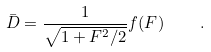Convert formula to latex. <formula><loc_0><loc_0><loc_500><loc_500>\bar { D } = \frac { 1 } { \sqrt { 1 + F ^ { 2 } / 2 } } f ( F ) \quad .</formula> 